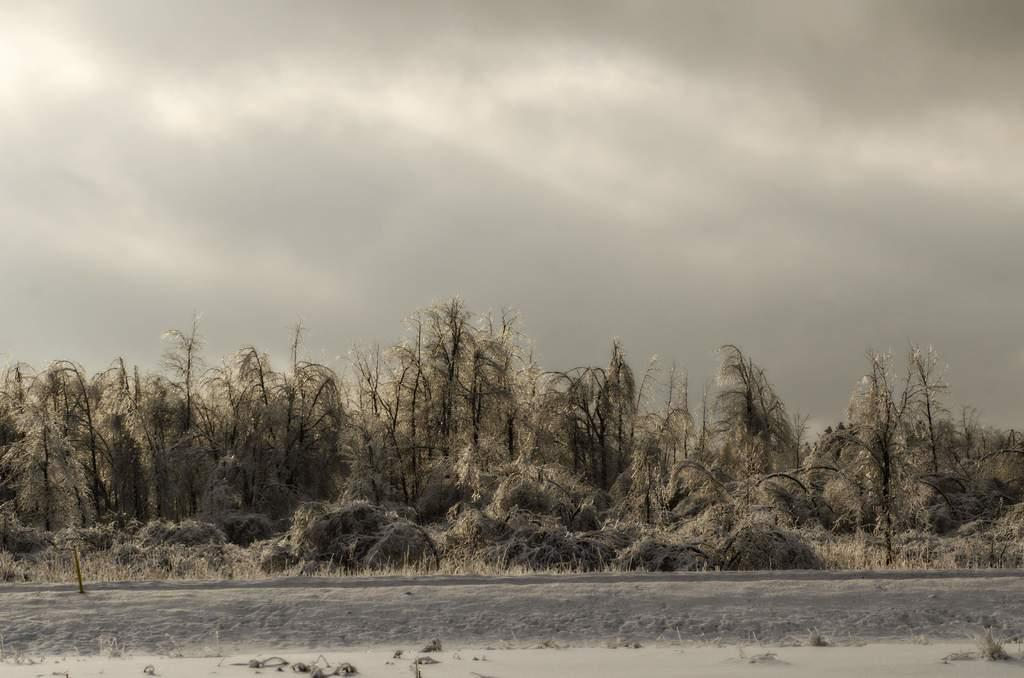What celestial body can be seen in the image? The sun is visible in the image. What type of vegetation is present in the image? There are trees in the image. What is the condition of the sky in the background of the image? The sky is cloudy in the background of the image. What type of mint is being discussed by the trees in the image? There is no mint or discussion present in the image; it features the sun, trees, and a cloudy sky. 